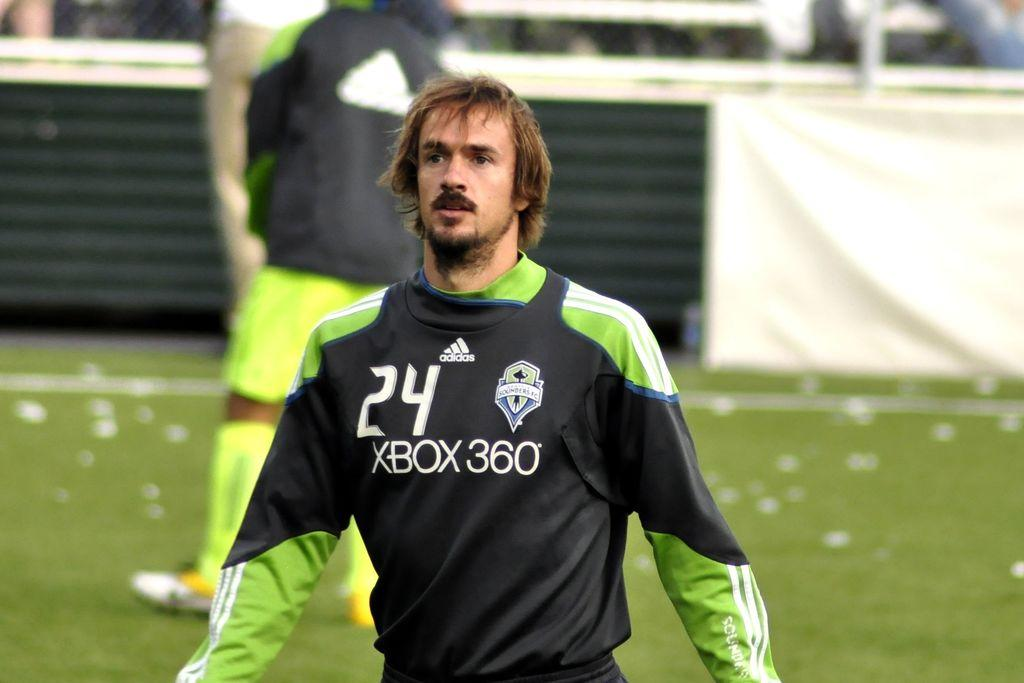What is the main subject in the foreground of the image? There is a person in the foreground of the image. Can you describe the setting in which the person is located? The person is standing in the grass. Are there any other people visible in the image? Yes, there are a few other persons standing in the grass in the background of the image. What type of linen is being used as a picnic blanket in the image? There is no picnic blanket present in the image, and therefore no linen can be observed. What type of attraction is the person in the foreground visiting in the image? There is no indication in the image of the person visiting any specific attraction. 